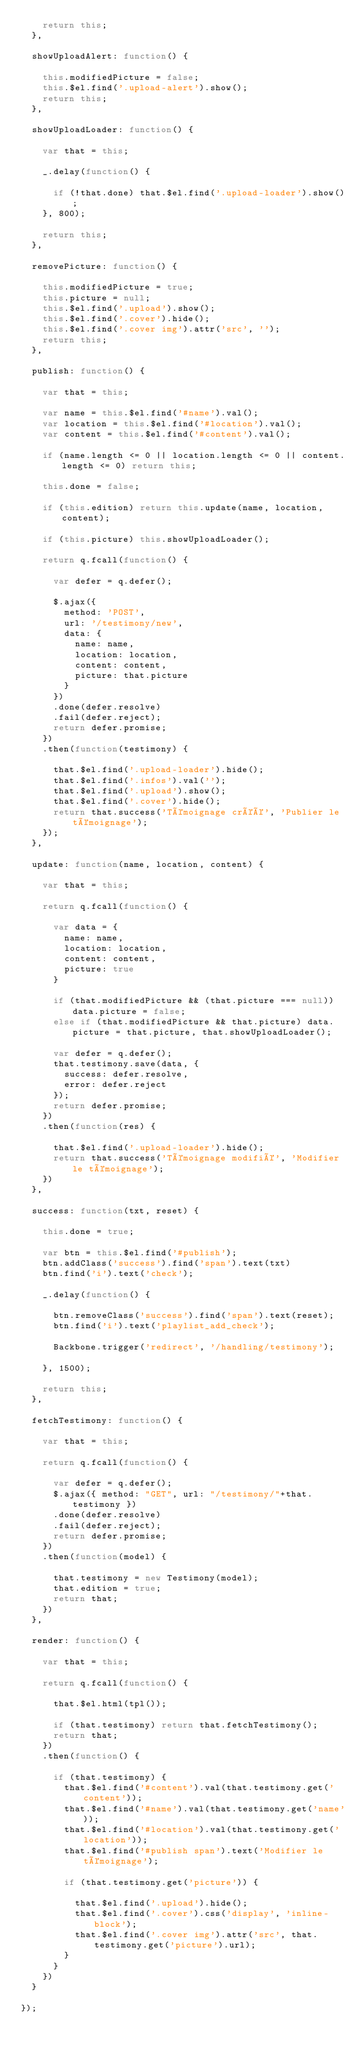Convert code to text. <code><loc_0><loc_0><loc_500><loc_500><_JavaScript_>    return this;
  },

  showUploadAlert: function() {

    this.modifiedPicture = false;
    this.$el.find('.upload-alert').show();
    return this;
  },

  showUploadLoader: function() {

    var that = this;

    _.delay(function() {

      if (!that.done) that.$el.find('.upload-loader').show();
    }, 800);

    return this;
  },

  removePicture: function() {

    this.modifiedPicture = true;
    this.picture = null;
    this.$el.find('.upload').show();
    this.$el.find('.cover').hide();
    this.$el.find('.cover img').attr('src', '');
    return this;
  },

  publish: function() {

    var that = this;

    var name = this.$el.find('#name').val();
    var location = this.$el.find('#location').val();
    var content = this.$el.find('#content').val();

    if (name.length <= 0 || location.length <= 0 || content.length <= 0) return this;

    this.done = false;

    if (this.edition) return this.update(name, location, content);

    if (this.picture) this.showUploadLoader();

    return q.fcall(function() {

      var defer = q.defer();

      $.ajax({
        method: 'POST',
        url: '/testimony/new',
        data: {
          name: name,
          location: location,
          content: content,
          picture: that.picture
        }
      })
      .done(defer.resolve)
      .fail(defer.reject);
      return defer.promise;
    })
    .then(function(testimony) {

      that.$el.find('.upload-loader').hide();
      that.$el.find('.infos').val('');
      that.$el.find('.upload').show();
      that.$el.find('.cover').hide();
      return that.success('Témoignage créé', 'Publier le témoignage');
    });
  },

  update: function(name, location, content) {

    var that = this;

    return q.fcall(function() {

      var data = {
        name: name,
        location: location,
        content: content,
        picture: true
      }

      if (that.modifiedPicture && (that.picture === null)) data.picture = false;
      else if (that.modifiedPicture && that.picture) data.picture = that.picture, that.showUploadLoader();

      var defer = q.defer();
      that.testimony.save(data, {
        success: defer.resolve,
        error: defer.reject
      });
      return defer.promise;
    })
    .then(function(res) {

      that.$el.find('.upload-loader').hide();
      return that.success('Témoignage modifié', 'Modifier le témoignage');
    })
  },

  success: function(txt, reset) {

    this.done = true;

    var btn = this.$el.find('#publish');
    btn.addClass('success').find('span').text(txt)
    btn.find('i').text('check');

    _.delay(function() {

      btn.removeClass('success').find('span').text(reset);
      btn.find('i').text('playlist_add_check');

      Backbone.trigger('redirect', '/handling/testimony');

    }, 1500);

    return this;
  },

  fetchTestimony: function() {

    var that = this;

    return q.fcall(function() {

      var defer = q.defer();
      $.ajax({ method: "GET", url: "/testimony/"+that.testimony })
      .done(defer.resolve)
      .fail(defer.reject);
      return defer.promise;
    })
    .then(function(model) {

      that.testimony = new Testimony(model);
      that.edition = true;
      return that;
    })
  },

  render: function() {

    var that = this;

    return q.fcall(function() {

      that.$el.html(tpl());

      if (that.testimony) return that.fetchTestimony();
      return that;
    })
    .then(function() {

      if (that.testimony) {
        that.$el.find('#content').val(that.testimony.get('content'));
        that.$el.find('#name').val(that.testimony.get('name'));
        that.$el.find('#location').val(that.testimony.get('location'));
        that.$el.find('#publish span').text('Modifier le témoignage');

        if (that.testimony.get('picture')) {

          that.$el.find('.upload').hide();
          that.$el.find('.cover').css('display', 'inline-block');
          that.$el.find('.cover img').attr('src', that.testimony.get('picture').url);
        }
      }
    })
  }

});
</code> 